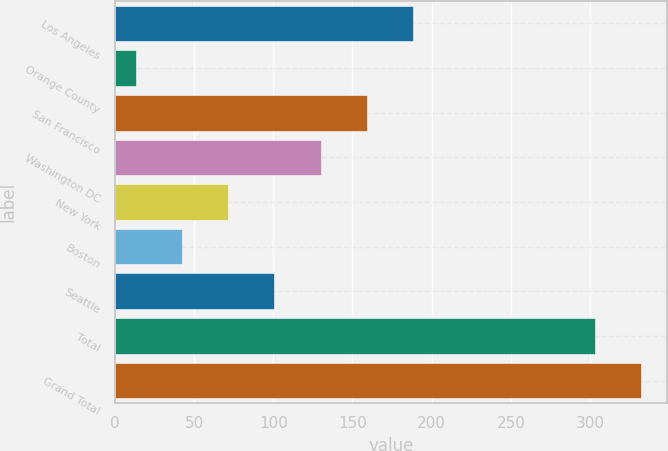Convert chart to OTSL. <chart><loc_0><loc_0><loc_500><loc_500><bar_chart><fcel>Los Angeles<fcel>Orange County<fcel>San Francisco<fcel>Washington DC<fcel>New York<fcel>Boston<fcel>Seattle<fcel>Total<fcel>Grand Total<nl><fcel>188.2<fcel>13<fcel>159<fcel>129.8<fcel>71.4<fcel>42.2<fcel>100.6<fcel>303<fcel>332.2<nl></chart> 